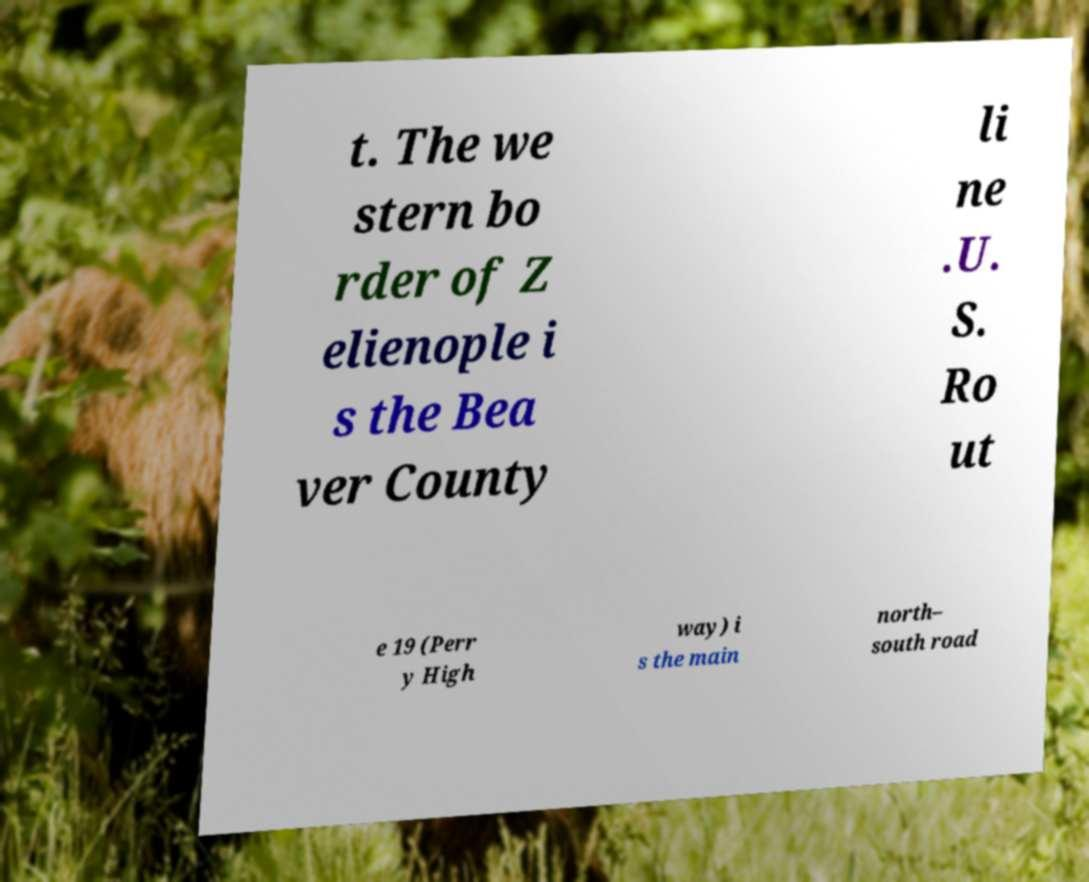What messages or text are displayed in this image? I need them in a readable, typed format. t. The we stern bo rder of Z elienople i s the Bea ver County li ne .U. S. Ro ut e 19 (Perr y High way) i s the main north– south road 